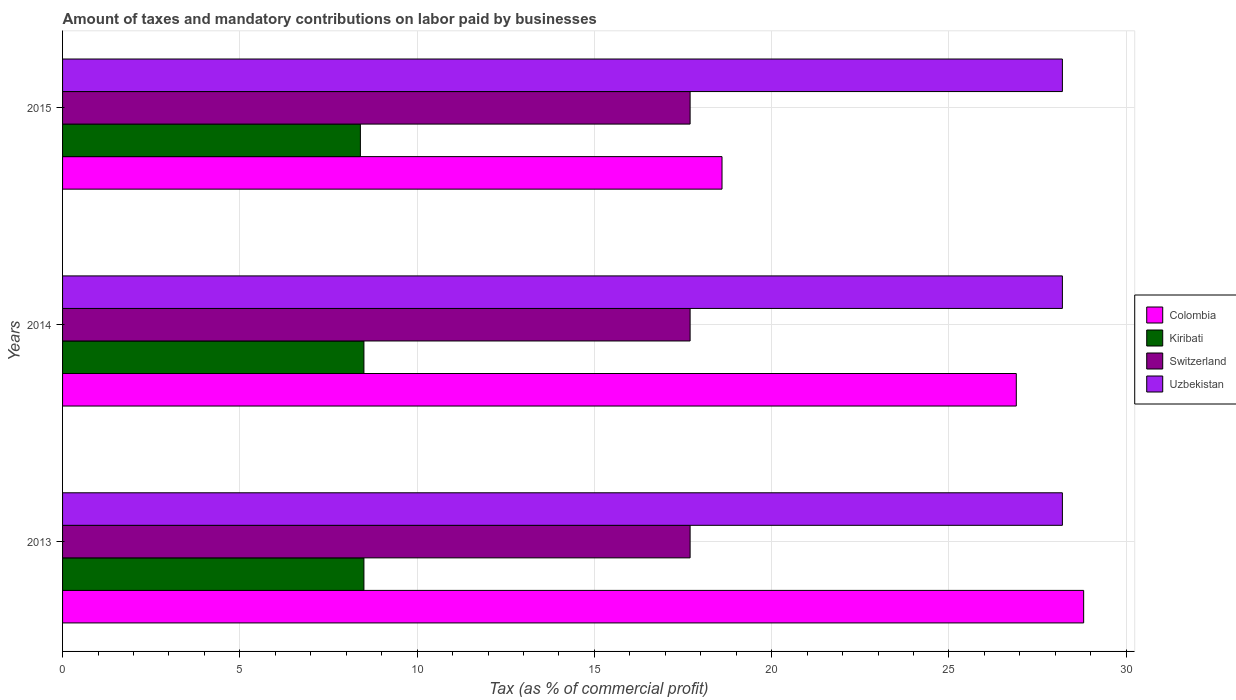How many different coloured bars are there?
Make the answer very short. 4. How many groups of bars are there?
Ensure brevity in your answer.  3. How many bars are there on the 2nd tick from the top?
Your answer should be compact. 4. What is the label of the 2nd group of bars from the top?
Give a very brief answer. 2014. In how many cases, is the number of bars for a given year not equal to the number of legend labels?
Offer a very short reply. 0. What is the percentage of taxes paid by businesses in Uzbekistan in 2013?
Provide a succinct answer. 28.2. Across all years, what is the maximum percentage of taxes paid by businesses in Switzerland?
Make the answer very short. 17.7. In which year was the percentage of taxes paid by businesses in Colombia minimum?
Offer a very short reply. 2015. What is the total percentage of taxes paid by businesses in Colombia in the graph?
Provide a short and direct response. 74.3. What is the difference between the percentage of taxes paid by businesses in Uzbekistan in 2013 and that in 2015?
Make the answer very short. 0. What is the difference between the percentage of taxes paid by businesses in Kiribati in 2013 and the percentage of taxes paid by businesses in Switzerland in 2015?
Provide a short and direct response. -9.2. What is the average percentage of taxes paid by businesses in Uzbekistan per year?
Provide a succinct answer. 28.2. In the year 2013, what is the difference between the percentage of taxes paid by businesses in Kiribati and percentage of taxes paid by businesses in Switzerland?
Your answer should be compact. -9.2. In how many years, is the percentage of taxes paid by businesses in Colombia greater than 2 %?
Keep it short and to the point. 3. What is the ratio of the percentage of taxes paid by businesses in Uzbekistan in 2013 to that in 2014?
Your response must be concise. 1. Is the difference between the percentage of taxes paid by businesses in Kiribati in 2014 and 2015 greater than the difference between the percentage of taxes paid by businesses in Switzerland in 2014 and 2015?
Provide a short and direct response. Yes. What is the difference between the highest and the second highest percentage of taxes paid by businesses in Kiribati?
Give a very brief answer. 0. What is the difference between the highest and the lowest percentage of taxes paid by businesses in Colombia?
Make the answer very short. 10.2. Is the sum of the percentage of taxes paid by businesses in Uzbekistan in 2013 and 2015 greater than the maximum percentage of taxes paid by businesses in Kiribati across all years?
Offer a very short reply. Yes. What does the 1st bar from the top in 2015 represents?
Provide a succinct answer. Uzbekistan. What does the 3rd bar from the bottom in 2013 represents?
Give a very brief answer. Switzerland. Is it the case that in every year, the sum of the percentage of taxes paid by businesses in Uzbekistan and percentage of taxes paid by businesses in Switzerland is greater than the percentage of taxes paid by businesses in Colombia?
Provide a short and direct response. Yes. How many bars are there?
Make the answer very short. 12. Are all the bars in the graph horizontal?
Offer a very short reply. Yes. How many years are there in the graph?
Your answer should be compact. 3. Are the values on the major ticks of X-axis written in scientific E-notation?
Ensure brevity in your answer.  No. Does the graph contain grids?
Offer a terse response. Yes. Where does the legend appear in the graph?
Keep it short and to the point. Center right. How many legend labels are there?
Provide a short and direct response. 4. How are the legend labels stacked?
Offer a very short reply. Vertical. What is the title of the graph?
Ensure brevity in your answer.  Amount of taxes and mandatory contributions on labor paid by businesses. What is the label or title of the X-axis?
Give a very brief answer. Tax (as % of commercial profit). What is the Tax (as % of commercial profit) of Colombia in 2013?
Make the answer very short. 28.8. What is the Tax (as % of commercial profit) of Kiribati in 2013?
Offer a terse response. 8.5. What is the Tax (as % of commercial profit) in Uzbekistan in 2013?
Offer a terse response. 28.2. What is the Tax (as % of commercial profit) in Colombia in 2014?
Your response must be concise. 26.9. What is the Tax (as % of commercial profit) of Kiribati in 2014?
Offer a very short reply. 8.5. What is the Tax (as % of commercial profit) of Uzbekistan in 2014?
Keep it short and to the point. 28.2. What is the Tax (as % of commercial profit) of Colombia in 2015?
Give a very brief answer. 18.6. What is the Tax (as % of commercial profit) of Switzerland in 2015?
Your answer should be very brief. 17.7. What is the Tax (as % of commercial profit) in Uzbekistan in 2015?
Offer a terse response. 28.2. Across all years, what is the maximum Tax (as % of commercial profit) in Colombia?
Your answer should be compact. 28.8. Across all years, what is the maximum Tax (as % of commercial profit) in Kiribati?
Your answer should be very brief. 8.5. Across all years, what is the maximum Tax (as % of commercial profit) in Switzerland?
Your answer should be very brief. 17.7. Across all years, what is the maximum Tax (as % of commercial profit) in Uzbekistan?
Ensure brevity in your answer.  28.2. Across all years, what is the minimum Tax (as % of commercial profit) of Switzerland?
Ensure brevity in your answer.  17.7. Across all years, what is the minimum Tax (as % of commercial profit) of Uzbekistan?
Your answer should be compact. 28.2. What is the total Tax (as % of commercial profit) in Colombia in the graph?
Offer a very short reply. 74.3. What is the total Tax (as % of commercial profit) in Kiribati in the graph?
Your answer should be compact. 25.4. What is the total Tax (as % of commercial profit) in Switzerland in the graph?
Provide a short and direct response. 53.1. What is the total Tax (as % of commercial profit) in Uzbekistan in the graph?
Your answer should be very brief. 84.6. What is the difference between the Tax (as % of commercial profit) in Kiribati in 2013 and that in 2014?
Keep it short and to the point. 0. What is the difference between the Tax (as % of commercial profit) of Switzerland in 2013 and that in 2014?
Your answer should be very brief. 0. What is the difference between the Tax (as % of commercial profit) of Uzbekistan in 2013 and that in 2014?
Your response must be concise. 0. What is the difference between the Tax (as % of commercial profit) in Kiribati in 2013 and that in 2015?
Provide a short and direct response. 0.1. What is the difference between the Tax (as % of commercial profit) of Colombia in 2014 and that in 2015?
Make the answer very short. 8.3. What is the difference between the Tax (as % of commercial profit) of Uzbekistan in 2014 and that in 2015?
Ensure brevity in your answer.  0. What is the difference between the Tax (as % of commercial profit) of Colombia in 2013 and the Tax (as % of commercial profit) of Kiribati in 2014?
Your response must be concise. 20.3. What is the difference between the Tax (as % of commercial profit) of Colombia in 2013 and the Tax (as % of commercial profit) of Switzerland in 2014?
Make the answer very short. 11.1. What is the difference between the Tax (as % of commercial profit) of Kiribati in 2013 and the Tax (as % of commercial profit) of Uzbekistan in 2014?
Your answer should be very brief. -19.7. What is the difference between the Tax (as % of commercial profit) in Colombia in 2013 and the Tax (as % of commercial profit) in Kiribati in 2015?
Your answer should be very brief. 20.4. What is the difference between the Tax (as % of commercial profit) in Colombia in 2013 and the Tax (as % of commercial profit) in Switzerland in 2015?
Your answer should be compact. 11.1. What is the difference between the Tax (as % of commercial profit) in Colombia in 2013 and the Tax (as % of commercial profit) in Uzbekistan in 2015?
Provide a succinct answer. 0.6. What is the difference between the Tax (as % of commercial profit) in Kiribati in 2013 and the Tax (as % of commercial profit) in Switzerland in 2015?
Your answer should be compact. -9.2. What is the difference between the Tax (as % of commercial profit) in Kiribati in 2013 and the Tax (as % of commercial profit) in Uzbekistan in 2015?
Keep it short and to the point. -19.7. What is the difference between the Tax (as % of commercial profit) of Switzerland in 2013 and the Tax (as % of commercial profit) of Uzbekistan in 2015?
Ensure brevity in your answer.  -10.5. What is the difference between the Tax (as % of commercial profit) in Kiribati in 2014 and the Tax (as % of commercial profit) in Uzbekistan in 2015?
Ensure brevity in your answer.  -19.7. What is the difference between the Tax (as % of commercial profit) of Switzerland in 2014 and the Tax (as % of commercial profit) of Uzbekistan in 2015?
Ensure brevity in your answer.  -10.5. What is the average Tax (as % of commercial profit) of Colombia per year?
Keep it short and to the point. 24.77. What is the average Tax (as % of commercial profit) of Kiribati per year?
Make the answer very short. 8.47. What is the average Tax (as % of commercial profit) of Uzbekistan per year?
Your response must be concise. 28.2. In the year 2013, what is the difference between the Tax (as % of commercial profit) in Colombia and Tax (as % of commercial profit) in Kiribati?
Ensure brevity in your answer.  20.3. In the year 2013, what is the difference between the Tax (as % of commercial profit) of Colombia and Tax (as % of commercial profit) of Switzerland?
Make the answer very short. 11.1. In the year 2013, what is the difference between the Tax (as % of commercial profit) of Kiribati and Tax (as % of commercial profit) of Switzerland?
Give a very brief answer. -9.2. In the year 2013, what is the difference between the Tax (as % of commercial profit) in Kiribati and Tax (as % of commercial profit) in Uzbekistan?
Ensure brevity in your answer.  -19.7. In the year 2014, what is the difference between the Tax (as % of commercial profit) of Colombia and Tax (as % of commercial profit) of Kiribati?
Offer a terse response. 18.4. In the year 2014, what is the difference between the Tax (as % of commercial profit) of Colombia and Tax (as % of commercial profit) of Switzerland?
Offer a very short reply. 9.2. In the year 2014, what is the difference between the Tax (as % of commercial profit) of Kiribati and Tax (as % of commercial profit) of Switzerland?
Give a very brief answer. -9.2. In the year 2014, what is the difference between the Tax (as % of commercial profit) in Kiribati and Tax (as % of commercial profit) in Uzbekistan?
Make the answer very short. -19.7. In the year 2015, what is the difference between the Tax (as % of commercial profit) in Colombia and Tax (as % of commercial profit) in Switzerland?
Give a very brief answer. 0.9. In the year 2015, what is the difference between the Tax (as % of commercial profit) in Kiribati and Tax (as % of commercial profit) in Uzbekistan?
Your response must be concise. -19.8. What is the ratio of the Tax (as % of commercial profit) in Colombia in 2013 to that in 2014?
Offer a very short reply. 1.07. What is the ratio of the Tax (as % of commercial profit) in Uzbekistan in 2013 to that in 2014?
Your response must be concise. 1. What is the ratio of the Tax (as % of commercial profit) of Colombia in 2013 to that in 2015?
Offer a terse response. 1.55. What is the ratio of the Tax (as % of commercial profit) in Kiribati in 2013 to that in 2015?
Your response must be concise. 1.01. What is the ratio of the Tax (as % of commercial profit) in Switzerland in 2013 to that in 2015?
Make the answer very short. 1. What is the ratio of the Tax (as % of commercial profit) of Colombia in 2014 to that in 2015?
Your answer should be compact. 1.45. What is the ratio of the Tax (as % of commercial profit) in Kiribati in 2014 to that in 2015?
Your answer should be compact. 1.01. What is the ratio of the Tax (as % of commercial profit) of Uzbekistan in 2014 to that in 2015?
Offer a terse response. 1. What is the difference between the highest and the second highest Tax (as % of commercial profit) of Colombia?
Ensure brevity in your answer.  1.9. What is the difference between the highest and the second highest Tax (as % of commercial profit) in Switzerland?
Your answer should be very brief. 0. What is the difference between the highest and the lowest Tax (as % of commercial profit) of Uzbekistan?
Your answer should be compact. 0. 